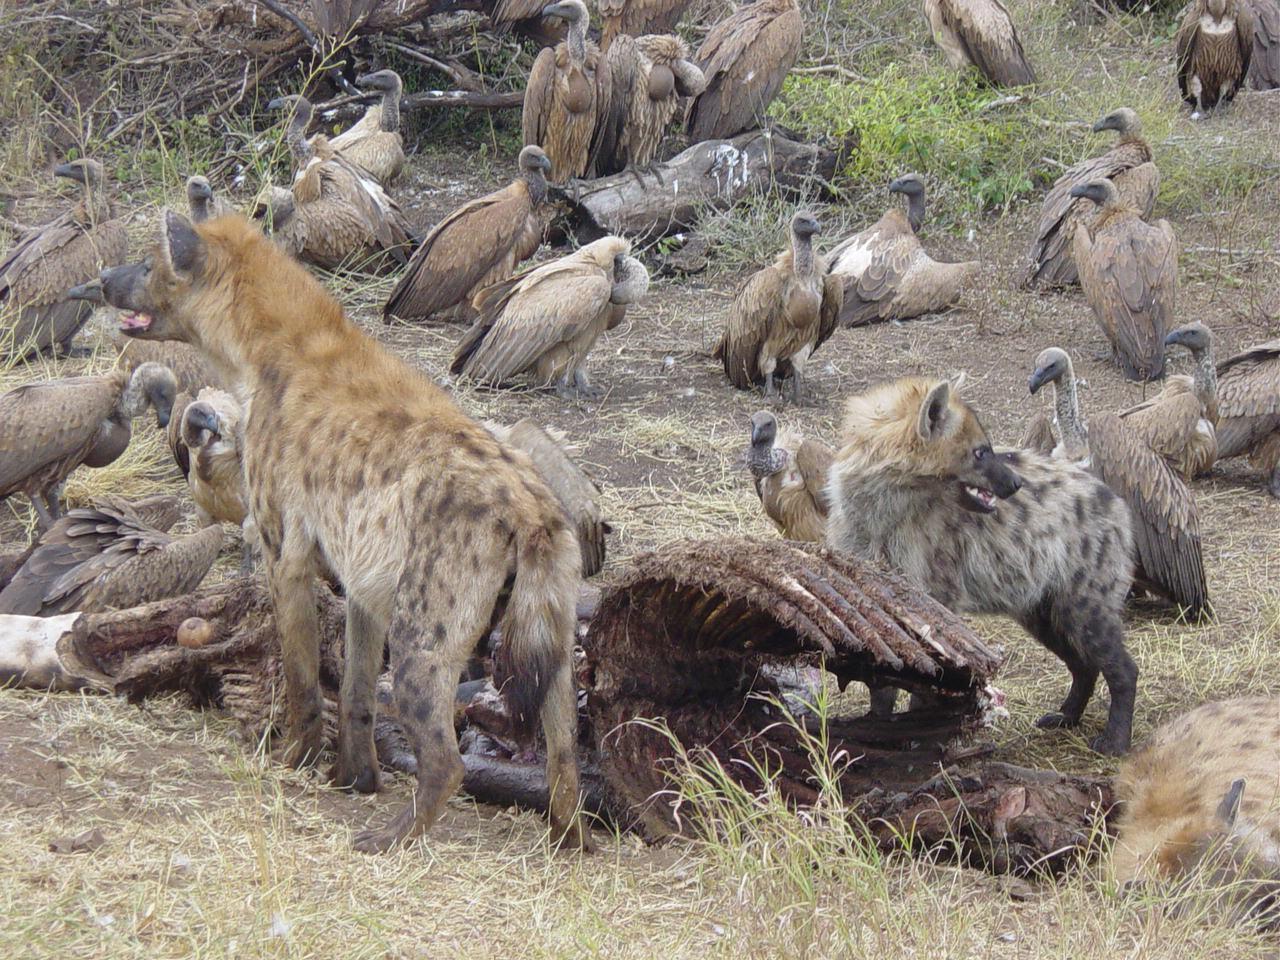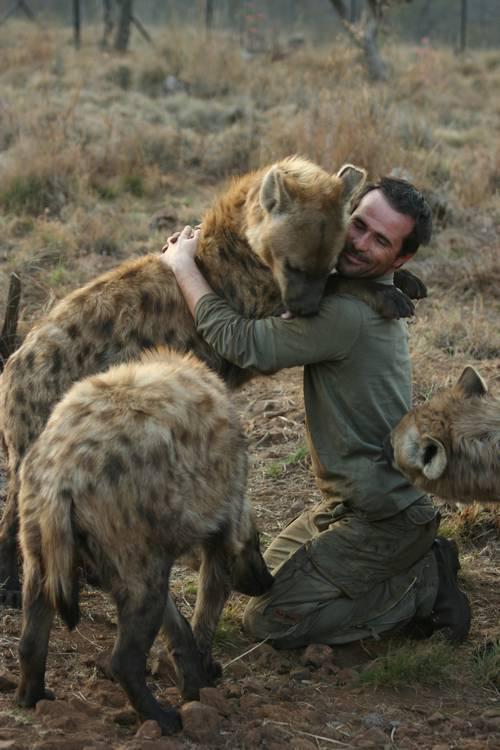The first image is the image on the left, the second image is the image on the right. For the images shown, is this caption "In the right image, a fang-baring open-mouthed hyena on the left is facing at least one canine of a different type on the right." true? Answer yes or no. No. The first image is the image on the left, the second image is the image on the right. Examine the images to the left and right. Is the description "There are three wild dogs with ones face pointed right showing teeth." accurate? Answer yes or no. No. 